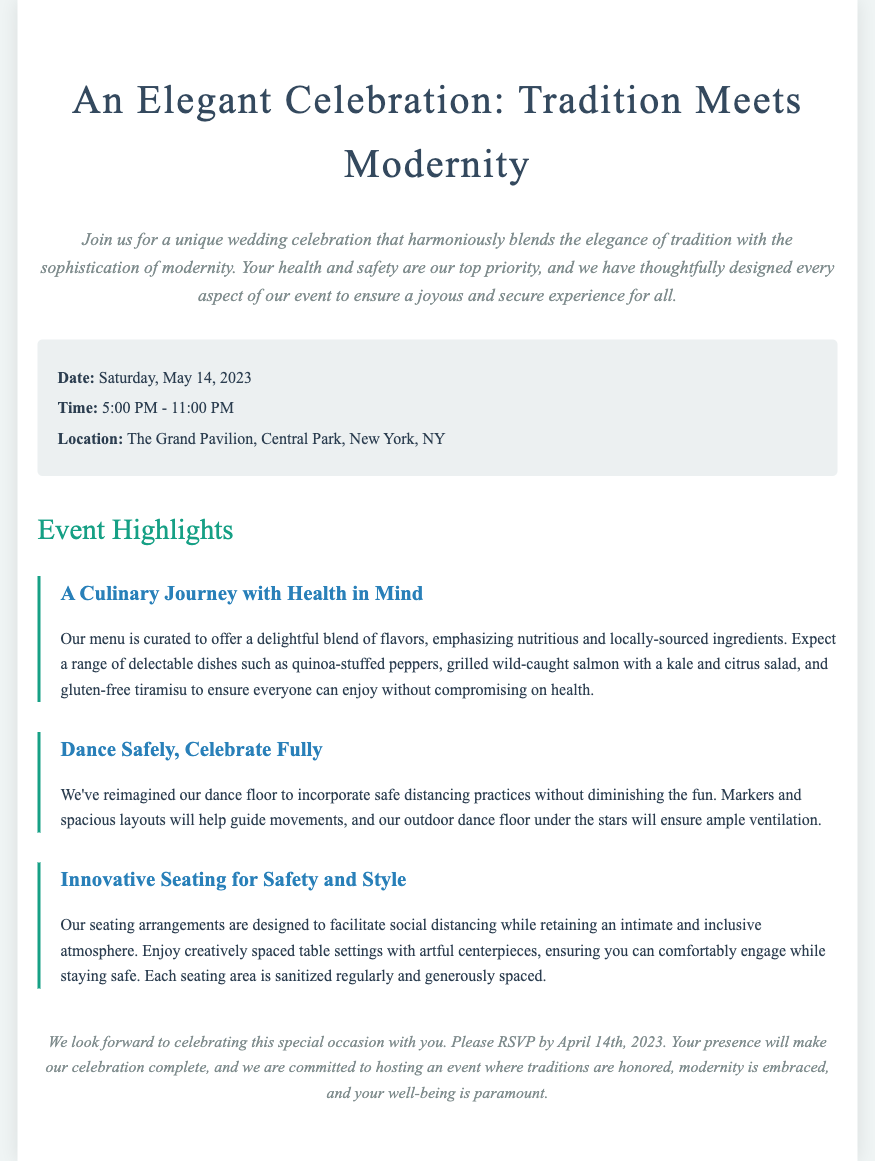what is the date of the wedding? The date is specified in the details section of the document.
Answer: Saturday, May 14, 2023 what is the location of the celebration? The location is provided in the details section of the document.
Answer: The Grand Pavilion, Central Park, New York, NY what type of menu options are featured? The document describes the menu as being health-conscious with specific mentions of dishes.
Answer: Nutritious and locally-sourced ingredients how is the dance floor arranged for safety? The reasoning requires understanding the adjustments made for safe dancing as mentioned in the document.
Answer: Safe distancing practices with markers and spacious layouts what must guests do by April 14th, 2023? The closing section prompts a certain action from the guests, indicating a deadline.
Answer: RSVP how has seating been arranged to ensure safety? This involves synthesizing information from the seating arrangement section.
Answer: Creatively spaced table settings what is the total duration of the wedding event? The time specified in the details gives the event's duration.
Answer: 6 hours (from 5:00 PM to 11:00 PM) how is ventilation ensured on the dance floor? The document mentions a specific feature regarding the dance floor that supports health safety.
Answer: Outdoor dance floor under the stars 